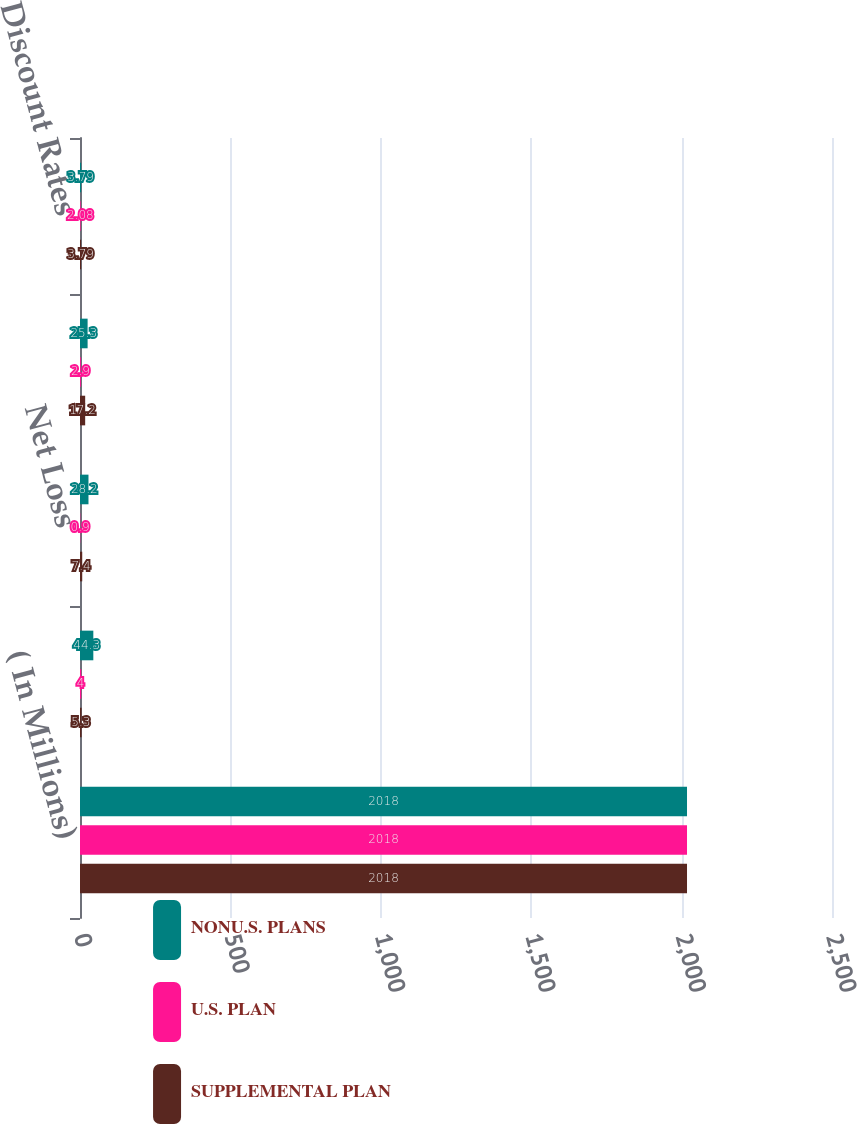<chart> <loc_0><loc_0><loc_500><loc_500><stacked_bar_chart><ecel><fcel>( In Millions)<fcel>Interest Cost<fcel>Net Loss<fcel>Net Periodic Pension Expense<fcel>Discount Rates<nl><fcel>NONU.S. PLANS<fcel>2018<fcel>44.3<fcel>28.2<fcel>25.3<fcel>3.79<nl><fcel>U.S. PLAN<fcel>2018<fcel>4<fcel>0.9<fcel>2.9<fcel>2.08<nl><fcel>SUPPLEMENTAL PLAN<fcel>2018<fcel>5.3<fcel>7.4<fcel>17.2<fcel>3.79<nl></chart> 